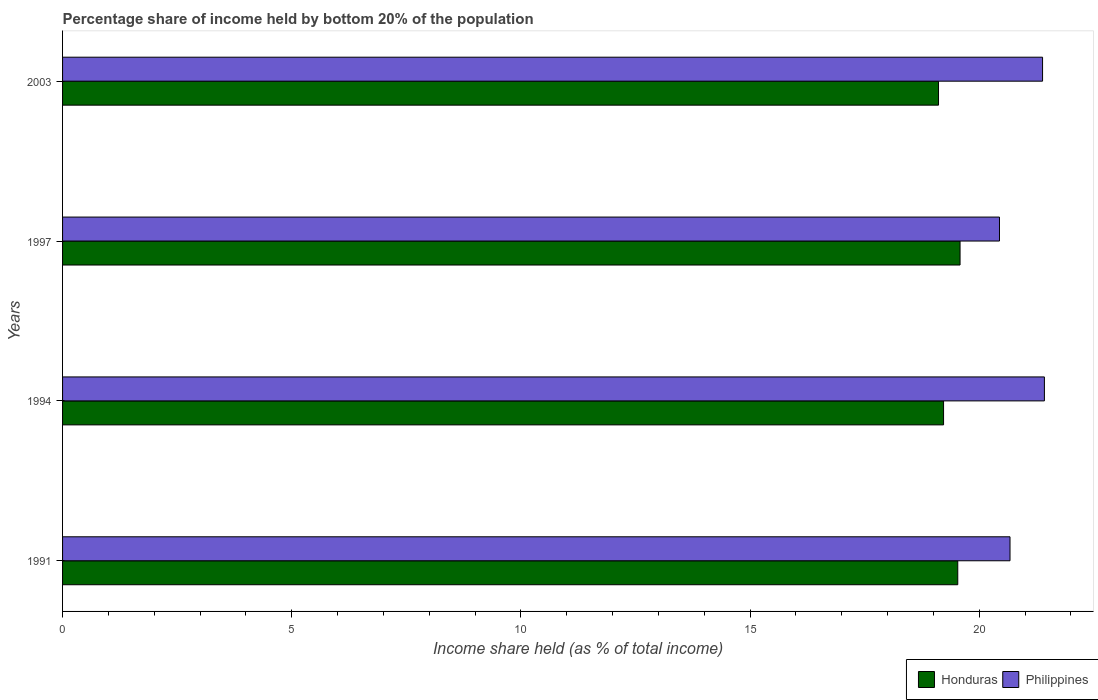How many different coloured bars are there?
Your response must be concise. 2. How many groups of bars are there?
Provide a succinct answer. 4. Are the number of bars per tick equal to the number of legend labels?
Offer a very short reply. Yes. How many bars are there on the 1st tick from the top?
Your response must be concise. 2. How many bars are there on the 1st tick from the bottom?
Your answer should be very brief. 2. What is the share of income held by bottom 20% of the population in Philippines in 2003?
Ensure brevity in your answer.  21.38. Across all years, what is the maximum share of income held by bottom 20% of the population in Honduras?
Your answer should be compact. 19.58. Across all years, what is the minimum share of income held by bottom 20% of the population in Honduras?
Offer a very short reply. 19.11. In which year was the share of income held by bottom 20% of the population in Philippines maximum?
Your answer should be very brief. 1994. What is the total share of income held by bottom 20% of the population in Honduras in the graph?
Ensure brevity in your answer.  77.44. What is the difference between the share of income held by bottom 20% of the population in Honduras in 1991 and that in 2003?
Give a very brief answer. 0.42. What is the difference between the share of income held by bottom 20% of the population in Philippines in 1994 and the share of income held by bottom 20% of the population in Honduras in 1997?
Your answer should be compact. 1.84. What is the average share of income held by bottom 20% of the population in Honduras per year?
Give a very brief answer. 19.36. In the year 1994, what is the difference between the share of income held by bottom 20% of the population in Honduras and share of income held by bottom 20% of the population in Philippines?
Provide a short and direct response. -2.2. In how many years, is the share of income held by bottom 20% of the population in Honduras greater than 6 %?
Give a very brief answer. 4. What is the ratio of the share of income held by bottom 20% of the population in Philippines in 1997 to that in 2003?
Make the answer very short. 0.96. What is the difference between the highest and the second highest share of income held by bottom 20% of the population in Honduras?
Ensure brevity in your answer.  0.05. What is the difference between the highest and the lowest share of income held by bottom 20% of the population in Philippines?
Your answer should be compact. 0.98. Is the sum of the share of income held by bottom 20% of the population in Honduras in 1991 and 1994 greater than the maximum share of income held by bottom 20% of the population in Philippines across all years?
Your response must be concise. Yes. What does the 2nd bar from the bottom in 2003 represents?
Make the answer very short. Philippines. How many bars are there?
Provide a short and direct response. 8. Are all the bars in the graph horizontal?
Your answer should be very brief. Yes. What is the difference between two consecutive major ticks on the X-axis?
Make the answer very short. 5. Are the values on the major ticks of X-axis written in scientific E-notation?
Provide a short and direct response. No. Does the graph contain any zero values?
Your answer should be compact. No. Does the graph contain grids?
Your answer should be very brief. No. How many legend labels are there?
Make the answer very short. 2. What is the title of the graph?
Ensure brevity in your answer.  Percentage share of income held by bottom 20% of the population. What is the label or title of the X-axis?
Your response must be concise. Income share held (as % of total income). What is the Income share held (as % of total income) in Honduras in 1991?
Offer a very short reply. 19.53. What is the Income share held (as % of total income) of Philippines in 1991?
Your answer should be very brief. 20.67. What is the Income share held (as % of total income) in Honduras in 1994?
Offer a terse response. 19.22. What is the Income share held (as % of total income) of Philippines in 1994?
Make the answer very short. 21.42. What is the Income share held (as % of total income) in Honduras in 1997?
Give a very brief answer. 19.58. What is the Income share held (as % of total income) of Philippines in 1997?
Ensure brevity in your answer.  20.44. What is the Income share held (as % of total income) in Honduras in 2003?
Your answer should be compact. 19.11. What is the Income share held (as % of total income) in Philippines in 2003?
Offer a very short reply. 21.38. Across all years, what is the maximum Income share held (as % of total income) in Honduras?
Provide a short and direct response. 19.58. Across all years, what is the maximum Income share held (as % of total income) of Philippines?
Your answer should be compact. 21.42. Across all years, what is the minimum Income share held (as % of total income) of Honduras?
Provide a short and direct response. 19.11. Across all years, what is the minimum Income share held (as % of total income) in Philippines?
Give a very brief answer. 20.44. What is the total Income share held (as % of total income) of Honduras in the graph?
Your answer should be very brief. 77.44. What is the total Income share held (as % of total income) in Philippines in the graph?
Your answer should be very brief. 83.91. What is the difference between the Income share held (as % of total income) of Honduras in 1991 and that in 1994?
Provide a short and direct response. 0.31. What is the difference between the Income share held (as % of total income) of Philippines in 1991 and that in 1994?
Your answer should be compact. -0.75. What is the difference between the Income share held (as % of total income) of Honduras in 1991 and that in 1997?
Offer a terse response. -0.05. What is the difference between the Income share held (as % of total income) of Philippines in 1991 and that in 1997?
Provide a succinct answer. 0.23. What is the difference between the Income share held (as % of total income) of Honduras in 1991 and that in 2003?
Your answer should be very brief. 0.42. What is the difference between the Income share held (as % of total income) of Philippines in 1991 and that in 2003?
Your response must be concise. -0.71. What is the difference between the Income share held (as % of total income) in Honduras in 1994 and that in 1997?
Give a very brief answer. -0.36. What is the difference between the Income share held (as % of total income) in Philippines in 1994 and that in 1997?
Your response must be concise. 0.98. What is the difference between the Income share held (as % of total income) of Honduras in 1994 and that in 2003?
Your answer should be very brief. 0.11. What is the difference between the Income share held (as % of total income) in Honduras in 1997 and that in 2003?
Offer a very short reply. 0.47. What is the difference between the Income share held (as % of total income) in Philippines in 1997 and that in 2003?
Your answer should be compact. -0.94. What is the difference between the Income share held (as % of total income) in Honduras in 1991 and the Income share held (as % of total income) in Philippines in 1994?
Ensure brevity in your answer.  -1.89. What is the difference between the Income share held (as % of total income) of Honduras in 1991 and the Income share held (as % of total income) of Philippines in 1997?
Provide a succinct answer. -0.91. What is the difference between the Income share held (as % of total income) in Honduras in 1991 and the Income share held (as % of total income) in Philippines in 2003?
Give a very brief answer. -1.85. What is the difference between the Income share held (as % of total income) in Honduras in 1994 and the Income share held (as % of total income) in Philippines in 1997?
Make the answer very short. -1.22. What is the difference between the Income share held (as % of total income) of Honduras in 1994 and the Income share held (as % of total income) of Philippines in 2003?
Give a very brief answer. -2.16. What is the difference between the Income share held (as % of total income) in Honduras in 1997 and the Income share held (as % of total income) in Philippines in 2003?
Provide a succinct answer. -1.8. What is the average Income share held (as % of total income) in Honduras per year?
Ensure brevity in your answer.  19.36. What is the average Income share held (as % of total income) of Philippines per year?
Provide a succinct answer. 20.98. In the year 1991, what is the difference between the Income share held (as % of total income) of Honduras and Income share held (as % of total income) of Philippines?
Give a very brief answer. -1.14. In the year 1994, what is the difference between the Income share held (as % of total income) of Honduras and Income share held (as % of total income) of Philippines?
Make the answer very short. -2.2. In the year 1997, what is the difference between the Income share held (as % of total income) in Honduras and Income share held (as % of total income) in Philippines?
Offer a very short reply. -0.86. In the year 2003, what is the difference between the Income share held (as % of total income) of Honduras and Income share held (as % of total income) of Philippines?
Offer a very short reply. -2.27. What is the ratio of the Income share held (as % of total income) in Honduras in 1991 to that in 1994?
Your answer should be very brief. 1.02. What is the ratio of the Income share held (as % of total income) in Philippines in 1991 to that in 1997?
Offer a very short reply. 1.01. What is the ratio of the Income share held (as % of total income) of Honduras in 1991 to that in 2003?
Give a very brief answer. 1.02. What is the ratio of the Income share held (as % of total income) in Philippines in 1991 to that in 2003?
Your answer should be very brief. 0.97. What is the ratio of the Income share held (as % of total income) of Honduras in 1994 to that in 1997?
Your response must be concise. 0.98. What is the ratio of the Income share held (as % of total income) of Philippines in 1994 to that in 1997?
Give a very brief answer. 1.05. What is the ratio of the Income share held (as % of total income) in Honduras in 1994 to that in 2003?
Offer a terse response. 1.01. What is the ratio of the Income share held (as % of total income) in Philippines in 1994 to that in 2003?
Your answer should be compact. 1. What is the ratio of the Income share held (as % of total income) in Honduras in 1997 to that in 2003?
Your answer should be very brief. 1.02. What is the ratio of the Income share held (as % of total income) in Philippines in 1997 to that in 2003?
Offer a terse response. 0.96. What is the difference between the highest and the second highest Income share held (as % of total income) in Honduras?
Offer a terse response. 0.05. What is the difference between the highest and the lowest Income share held (as % of total income) of Honduras?
Provide a short and direct response. 0.47. What is the difference between the highest and the lowest Income share held (as % of total income) in Philippines?
Your answer should be very brief. 0.98. 